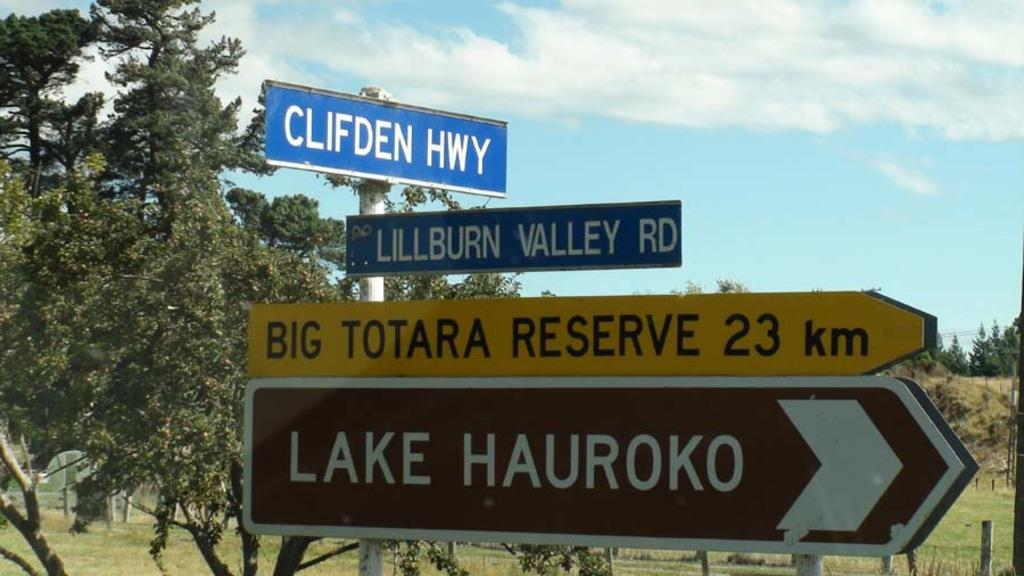<image>
Summarize the visual content of the image. Many street signs such as, Clifden HWY are on the side of a road. 